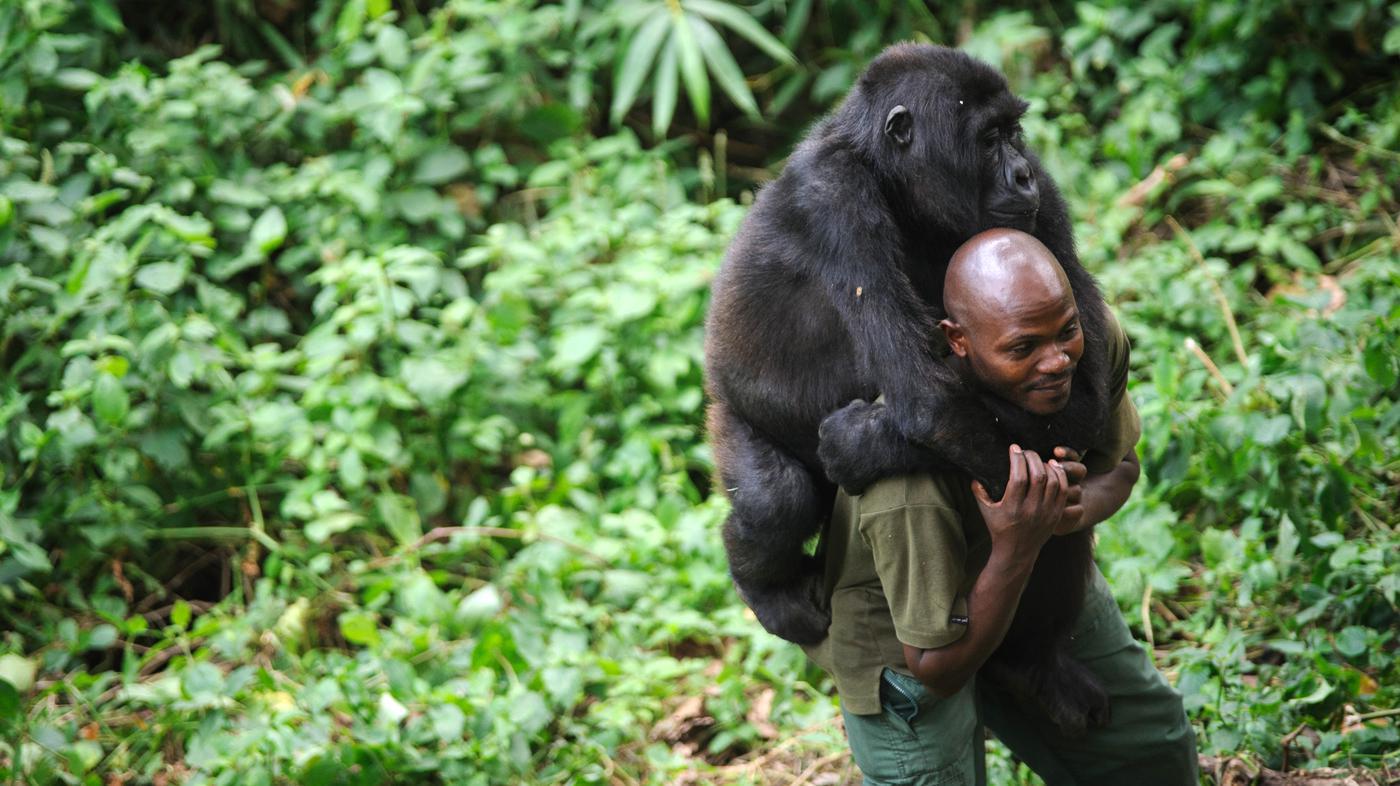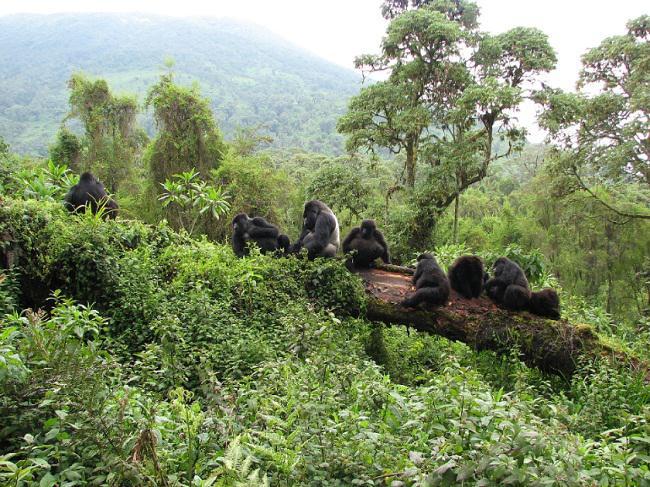The first image is the image on the left, the second image is the image on the right. For the images shown, is this caption "One image contains at least eight apes." true? Answer yes or no. Yes. The first image is the image on the left, the second image is the image on the right. Examine the images to the left and right. Is the description "A group of four or more gorillas is assembled in the forest." accurate? Answer yes or no. Yes. 